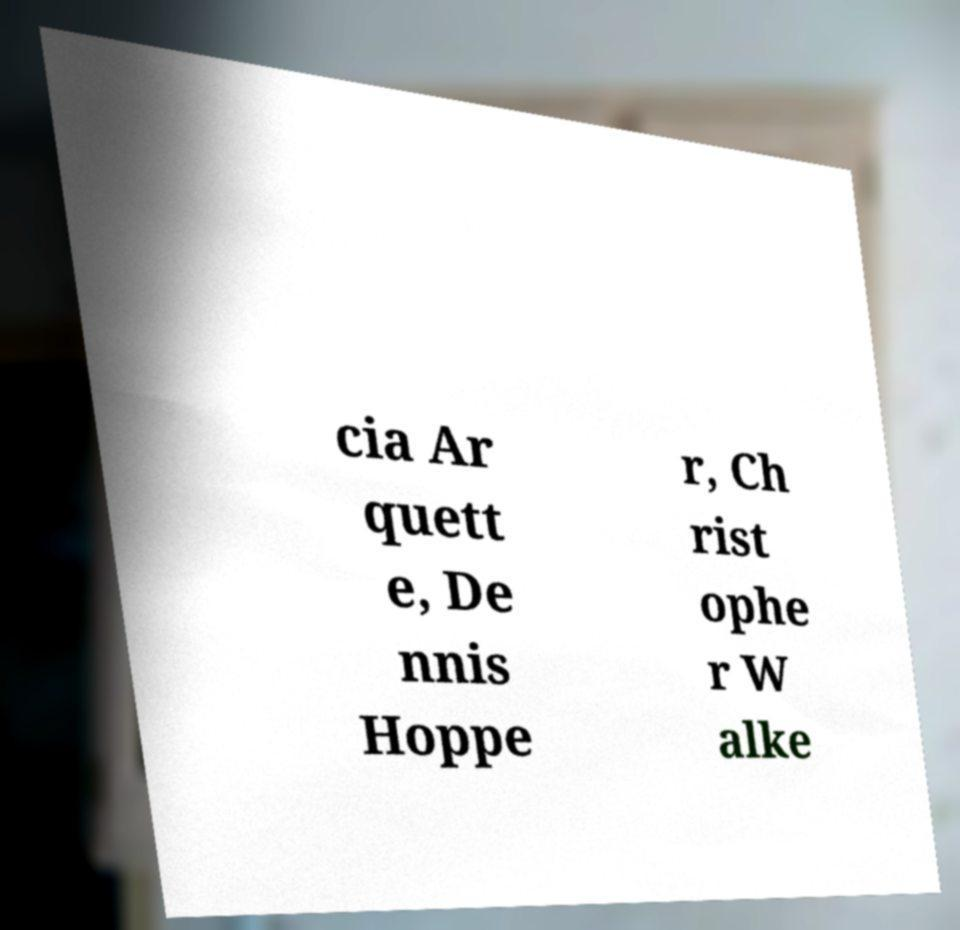Please read and relay the text visible in this image. What does it say? cia Ar quett e, De nnis Hoppe r, Ch rist ophe r W alke 